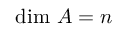<formula> <loc_0><loc_0><loc_500><loc_500>{ d i m } A = n</formula> 